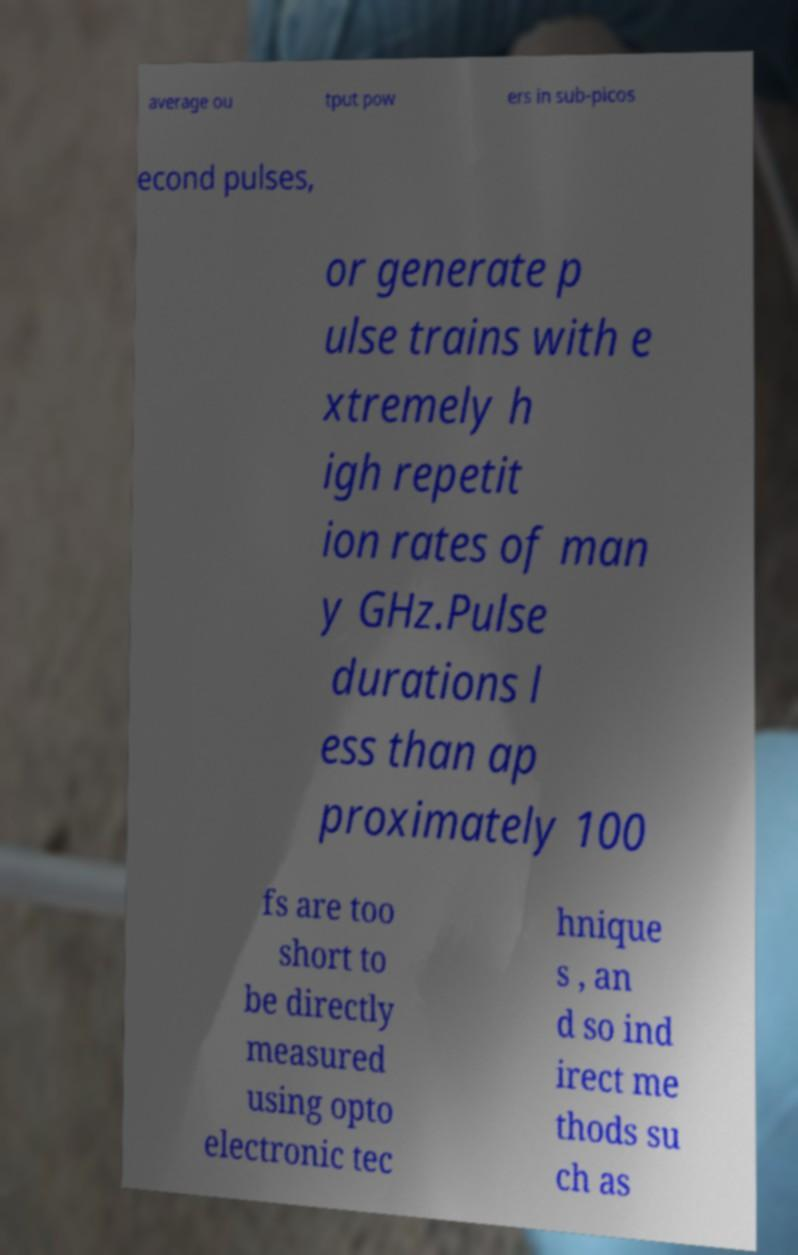Can you accurately transcribe the text from the provided image for me? average ou tput pow ers in sub-picos econd pulses, or generate p ulse trains with e xtremely h igh repetit ion rates of man y GHz.Pulse durations l ess than ap proximately 100 fs are too short to be directly measured using opto electronic tec hnique s , an d so ind irect me thods su ch as 